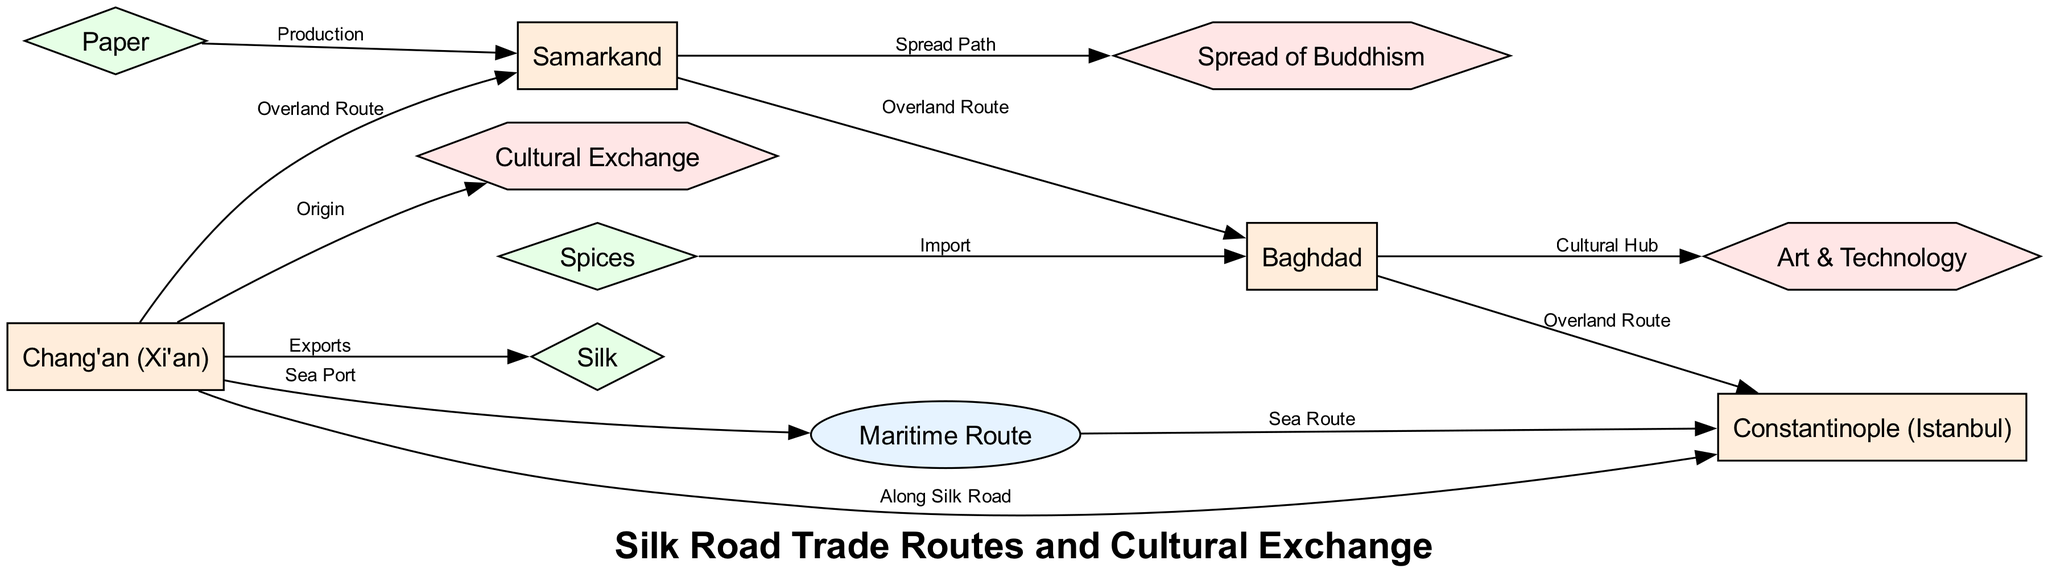What cities are connected by the Overland Route? The edges labeled "Overland Route" directly connect Chang'an to Samarkand, Samarkand to Baghdad, and Baghdad to Constantinople. By identifying these connections, we can delineate which cities share this particular route.
Answer: Chang'an, Samarkand, Baghdad, Constantinople How many goods are represented in the diagram? The 'goods' type nodes in the diagram are silk, spices, and paper. Counting these distinct goods nodes gives us the total number.
Answer: 3 What is the primary good exported from Chang'an? In the diagram, Chang'an has an edge labeled "Exports" pointing to silk. This indicates that silk is the main good exported from Chang'an.
Answer: Silk Which city serves as a cultural hub for art and technology? The edge labeled "Cultural Hub" connects Baghdad to art and technology. This implies that Baghdad plays a significant role in the diffusion of art and technology along the Silk Road.
Answer: Baghdad What route connects Chang'an to Constantinople? The diagram shows two edges connecting Chang'an to Constantinople: one labeled "Along Silk Road" and another edge labeled "Sea Route" connecting through the maritime node. This indicates there are multiple routes including overland and maritime that link the two cities.
Answer: Along Silk Road, Sea Route Which goods flow from Samarkand? The node for paper in the diagram connects to Samarkand with an edge labeled "Production." This indicates that Samarkand is a source for the production of paper, making it a relevant good tied to this city.
Answer: Paper How is Buddhism spread according to the diagram? The diagram shows an edge labeled "Spread Path" connecting Samarkand to Buddhism. This indicates that Samarkand is a crucial node in the transmission of Buddhism along the Silk Road.
Answer: Samarkand What is the total number of nodes in the diagram? By counting all the distinct nodes listed, which includes cities, goods, routes, and cultural exchanges, we find that there are a total of 10 nodes in the diagram.
Answer: 10 What kind of route does the maritime path indicate? The edge labeled "Sea Route" going from the maritime node to Constantinople indicates that it is a maritime trade route. This implies a mode of trade or cultural exchange via sea.
Answer: Sea Route 